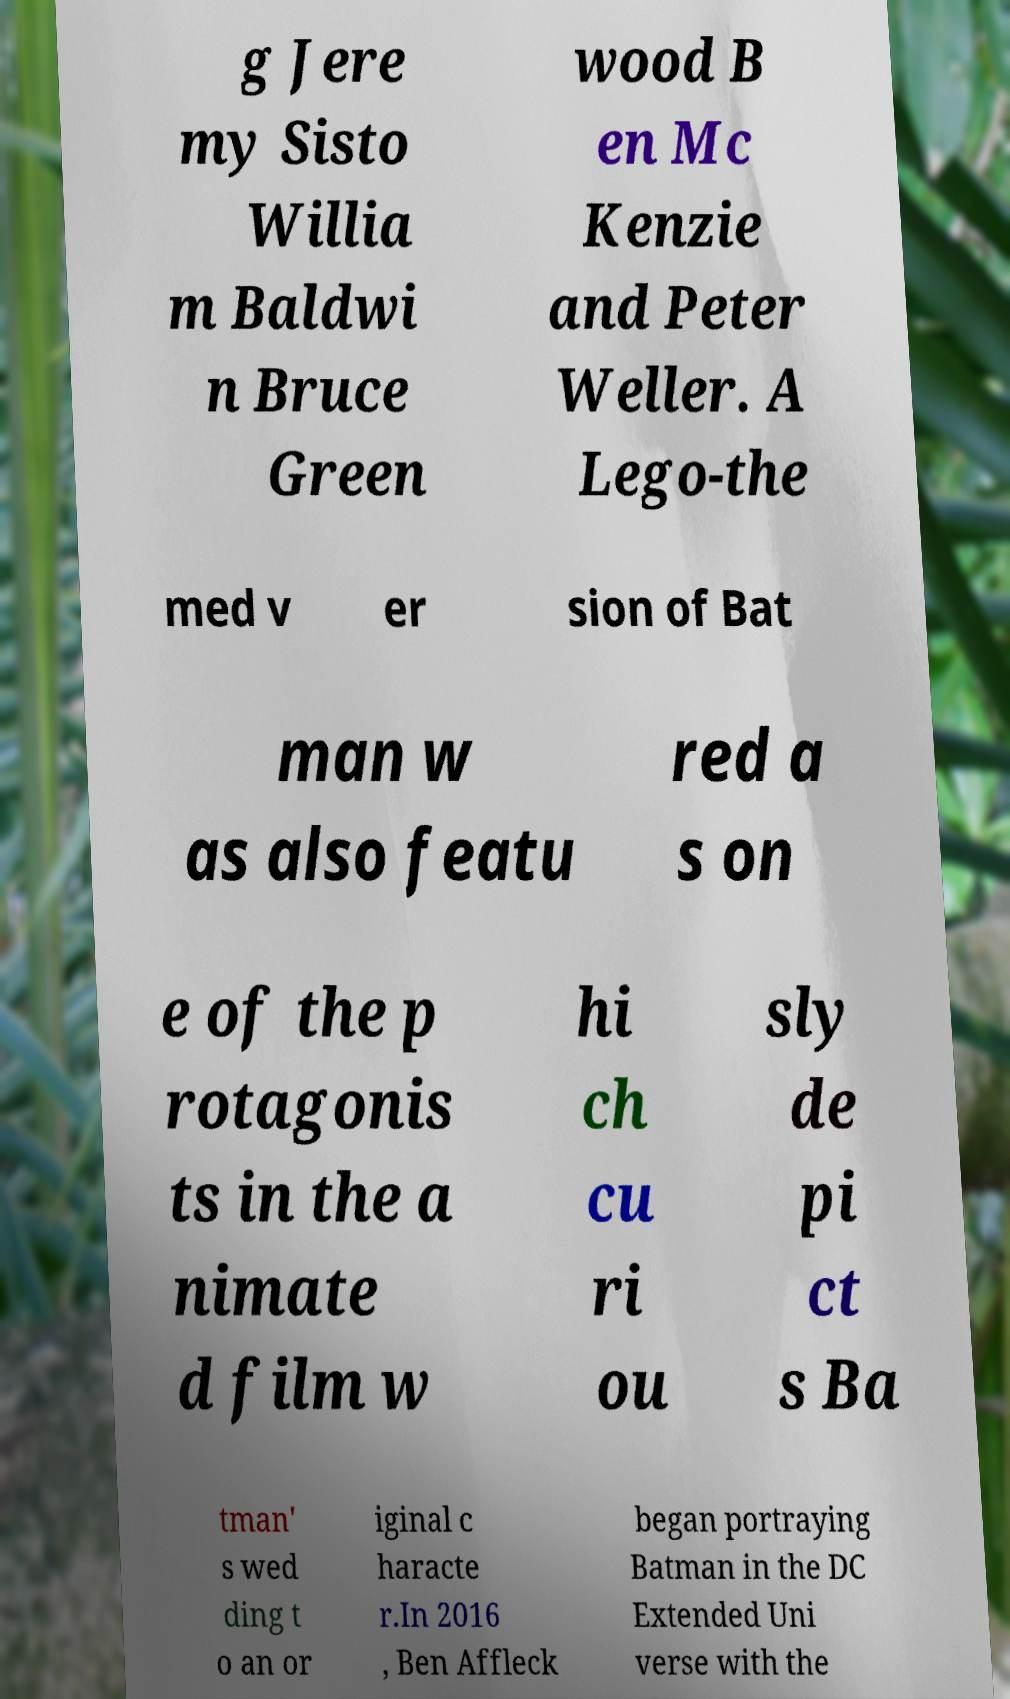Can you read and provide the text displayed in the image?This photo seems to have some interesting text. Can you extract and type it out for me? g Jere my Sisto Willia m Baldwi n Bruce Green wood B en Mc Kenzie and Peter Weller. A Lego-the med v er sion of Bat man w as also featu red a s on e of the p rotagonis ts in the a nimate d film w hi ch cu ri ou sly de pi ct s Ba tman' s wed ding t o an or iginal c haracte r.In 2016 , Ben Affleck began portraying Batman in the DC Extended Uni verse with the 